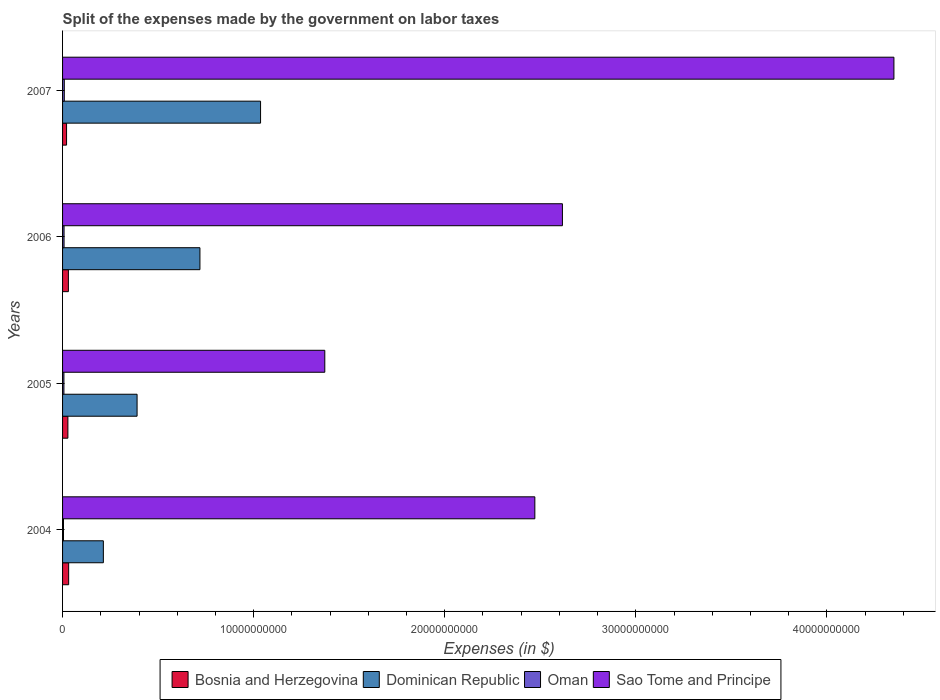How many groups of bars are there?
Ensure brevity in your answer.  4. How many bars are there on the 1st tick from the top?
Provide a short and direct response. 4. What is the label of the 4th group of bars from the top?
Make the answer very short. 2004. What is the expenses made by the government on labor taxes in Sao Tome and Principe in 2005?
Provide a short and direct response. 1.37e+1. Across all years, what is the maximum expenses made by the government on labor taxes in Dominican Republic?
Give a very brief answer. 1.04e+1. Across all years, what is the minimum expenses made by the government on labor taxes in Dominican Republic?
Offer a very short reply. 2.13e+09. In which year was the expenses made by the government on labor taxes in Dominican Republic minimum?
Provide a short and direct response. 2004. What is the total expenses made by the government on labor taxes in Dominican Republic in the graph?
Make the answer very short. 2.36e+1. What is the difference between the expenses made by the government on labor taxes in Sao Tome and Principe in 2004 and that in 2007?
Provide a short and direct response. -1.88e+1. What is the difference between the expenses made by the government on labor taxes in Sao Tome and Principe in 2004 and the expenses made by the government on labor taxes in Bosnia and Herzegovina in 2006?
Your response must be concise. 2.44e+1. What is the average expenses made by the government on labor taxes in Oman per year?
Your answer should be compact. 7.24e+07. In the year 2005, what is the difference between the expenses made by the government on labor taxes in Dominican Republic and expenses made by the government on labor taxes in Sao Tome and Principe?
Offer a very short reply. -9.82e+09. What is the ratio of the expenses made by the government on labor taxes in Bosnia and Herzegovina in 2004 to that in 2005?
Provide a short and direct response. 1.14. Is the expenses made by the government on labor taxes in Dominican Republic in 2005 less than that in 2006?
Your answer should be compact. Yes. Is the difference between the expenses made by the government on labor taxes in Dominican Republic in 2004 and 2007 greater than the difference between the expenses made by the government on labor taxes in Sao Tome and Principe in 2004 and 2007?
Your answer should be compact. Yes. What is the difference between the highest and the second highest expenses made by the government on labor taxes in Bosnia and Herzegovina?
Your answer should be compact. 1.43e+07. What is the difference between the highest and the lowest expenses made by the government on labor taxes in Oman?
Give a very brief answer. 4.18e+07. What does the 4th bar from the top in 2004 represents?
Provide a short and direct response. Bosnia and Herzegovina. What does the 1st bar from the bottom in 2006 represents?
Offer a very short reply. Bosnia and Herzegovina. Is it the case that in every year, the sum of the expenses made by the government on labor taxes in Bosnia and Herzegovina and expenses made by the government on labor taxes in Dominican Republic is greater than the expenses made by the government on labor taxes in Sao Tome and Principe?
Provide a succinct answer. No. How many bars are there?
Your answer should be very brief. 16. How many years are there in the graph?
Your answer should be compact. 4. Does the graph contain grids?
Give a very brief answer. No. Where does the legend appear in the graph?
Offer a very short reply. Bottom center. How are the legend labels stacked?
Your response must be concise. Horizontal. What is the title of the graph?
Your response must be concise. Split of the expenses made by the government on labor taxes. What is the label or title of the X-axis?
Ensure brevity in your answer.  Expenses (in $). What is the label or title of the Y-axis?
Make the answer very short. Years. What is the Expenses (in $) of Bosnia and Herzegovina in 2004?
Your answer should be very brief. 3.19e+08. What is the Expenses (in $) of Dominican Republic in 2004?
Give a very brief answer. 2.13e+09. What is the Expenses (in $) in Oman in 2004?
Your answer should be compact. 4.91e+07. What is the Expenses (in $) of Sao Tome and Principe in 2004?
Offer a very short reply. 2.47e+1. What is the Expenses (in $) in Bosnia and Herzegovina in 2005?
Make the answer very short. 2.79e+08. What is the Expenses (in $) in Dominican Republic in 2005?
Make the answer very short. 3.90e+09. What is the Expenses (in $) in Oman in 2005?
Make the answer very short. 7.12e+07. What is the Expenses (in $) in Sao Tome and Principe in 2005?
Make the answer very short. 1.37e+1. What is the Expenses (in $) in Bosnia and Herzegovina in 2006?
Ensure brevity in your answer.  3.04e+08. What is the Expenses (in $) in Dominican Republic in 2006?
Offer a terse response. 7.19e+09. What is the Expenses (in $) of Oman in 2006?
Offer a very short reply. 7.82e+07. What is the Expenses (in $) in Sao Tome and Principe in 2006?
Your response must be concise. 2.62e+1. What is the Expenses (in $) of Bosnia and Herzegovina in 2007?
Provide a succinct answer. 2.09e+08. What is the Expenses (in $) in Dominican Republic in 2007?
Your answer should be very brief. 1.04e+1. What is the Expenses (in $) in Oman in 2007?
Offer a very short reply. 9.09e+07. What is the Expenses (in $) in Sao Tome and Principe in 2007?
Provide a succinct answer. 4.35e+1. Across all years, what is the maximum Expenses (in $) in Bosnia and Herzegovina?
Provide a succinct answer. 3.19e+08. Across all years, what is the maximum Expenses (in $) of Dominican Republic?
Your answer should be very brief. 1.04e+1. Across all years, what is the maximum Expenses (in $) in Oman?
Provide a short and direct response. 9.09e+07. Across all years, what is the maximum Expenses (in $) in Sao Tome and Principe?
Provide a short and direct response. 4.35e+1. Across all years, what is the minimum Expenses (in $) in Bosnia and Herzegovina?
Make the answer very short. 2.09e+08. Across all years, what is the minimum Expenses (in $) of Dominican Republic?
Ensure brevity in your answer.  2.13e+09. Across all years, what is the minimum Expenses (in $) of Oman?
Offer a terse response. 4.91e+07. Across all years, what is the minimum Expenses (in $) of Sao Tome and Principe?
Ensure brevity in your answer.  1.37e+1. What is the total Expenses (in $) of Bosnia and Herzegovina in the graph?
Your answer should be compact. 1.11e+09. What is the total Expenses (in $) in Dominican Republic in the graph?
Provide a succinct answer. 2.36e+1. What is the total Expenses (in $) of Oman in the graph?
Your answer should be compact. 2.89e+08. What is the total Expenses (in $) of Sao Tome and Principe in the graph?
Offer a terse response. 1.08e+11. What is the difference between the Expenses (in $) of Bosnia and Herzegovina in 2004 and that in 2005?
Offer a very short reply. 3.98e+07. What is the difference between the Expenses (in $) of Dominican Republic in 2004 and that in 2005?
Offer a terse response. -1.76e+09. What is the difference between the Expenses (in $) of Oman in 2004 and that in 2005?
Ensure brevity in your answer.  -2.21e+07. What is the difference between the Expenses (in $) in Sao Tome and Principe in 2004 and that in 2005?
Your answer should be compact. 1.10e+1. What is the difference between the Expenses (in $) in Bosnia and Herzegovina in 2004 and that in 2006?
Your answer should be compact. 1.43e+07. What is the difference between the Expenses (in $) of Dominican Republic in 2004 and that in 2006?
Offer a very short reply. -5.05e+09. What is the difference between the Expenses (in $) of Oman in 2004 and that in 2006?
Make the answer very short. -2.91e+07. What is the difference between the Expenses (in $) in Sao Tome and Principe in 2004 and that in 2006?
Provide a succinct answer. -1.44e+09. What is the difference between the Expenses (in $) of Bosnia and Herzegovina in 2004 and that in 2007?
Offer a very short reply. 1.10e+08. What is the difference between the Expenses (in $) of Dominican Republic in 2004 and that in 2007?
Your response must be concise. -8.23e+09. What is the difference between the Expenses (in $) of Oman in 2004 and that in 2007?
Your response must be concise. -4.18e+07. What is the difference between the Expenses (in $) in Sao Tome and Principe in 2004 and that in 2007?
Provide a short and direct response. -1.88e+1. What is the difference between the Expenses (in $) of Bosnia and Herzegovina in 2005 and that in 2006?
Provide a succinct answer. -2.55e+07. What is the difference between the Expenses (in $) in Dominican Republic in 2005 and that in 2006?
Your response must be concise. -3.29e+09. What is the difference between the Expenses (in $) of Oman in 2005 and that in 2006?
Provide a short and direct response. -7.00e+06. What is the difference between the Expenses (in $) in Sao Tome and Principe in 2005 and that in 2006?
Your answer should be very brief. -1.24e+1. What is the difference between the Expenses (in $) in Bosnia and Herzegovina in 2005 and that in 2007?
Offer a terse response. 7.00e+07. What is the difference between the Expenses (in $) of Dominican Republic in 2005 and that in 2007?
Your response must be concise. -6.46e+09. What is the difference between the Expenses (in $) of Oman in 2005 and that in 2007?
Ensure brevity in your answer.  -1.97e+07. What is the difference between the Expenses (in $) in Sao Tome and Principe in 2005 and that in 2007?
Provide a succinct answer. -2.98e+1. What is the difference between the Expenses (in $) in Bosnia and Herzegovina in 2006 and that in 2007?
Your response must be concise. 9.55e+07. What is the difference between the Expenses (in $) in Dominican Republic in 2006 and that in 2007?
Provide a succinct answer. -3.17e+09. What is the difference between the Expenses (in $) in Oman in 2006 and that in 2007?
Provide a succinct answer. -1.27e+07. What is the difference between the Expenses (in $) in Sao Tome and Principe in 2006 and that in 2007?
Your response must be concise. -1.73e+1. What is the difference between the Expenses (in $) in Bosnia and Herzegovina in 2004 and the Expenses (in $) in Dominican Republic in 2005?
Your response must be concise. -3.58e+09. What is the difference between the Expenses (in $) of Bosnia and Herzegovina in 2004 and the Expenses (in $) of Oman in 2005?
Offer a very short reply. 2.48e+08. What is the difference between the Expenses (in $) in Bosnia and Herzegovina in 2004 and the Expenses (in $) in Sao Tome and Principe in 2005?
Give a very brief answer. -1.34e+1. What is the difference between the Expenses (in $) in Dominican Republic in 2004 and the Expenses (in $) in Oman in 2005?
Your answer should be compact. 2.06e+09. What is the difference between the Expenses (in $) of Dominican Republic in 2004 and the Expenses (in $) of Sao Tome and Principe in 2005?
Provide a short and direct response. -1.16e+1. What is the difference between the Expenses (in $) in Oman in 2004 and the Expenses (in $) in Sao Tome and Principe in 2005?
Provide a short and direct response. -1.37e+1. What is the difference between the Expenses (in $) in Bosnia and Herzegovina in 2004 and the Expenses (in $) in Dominican Republic in 2006?
Offer a terse response. -6.87e+09. What is the difference between the Expenses (in $) of Bosnia and Herzegovina in 2004 and the Expenses (in $) of Oman in 2006?
Provide a succinct answer. 2.41e+08. What is the difference between the Expenses (in $) of Bosnia and Herzegovina in 2004 and the Expenses (in $) of Sao Tome and Principe in 2006?
Your response must be concise. -2.58e+1. What is the difference between the Expenses (in $) of Dominican Republic in 2004 and the Expenses (in $) of Oman in 2006?
Your answer should be very brief. 2.06e+09. What is the difference between the Expenses (in $) of Dominican Republic in 2004 and the Expenses (in $) of Sao Tome and Principe in 2006?
Offer a terse response. -2.40e+1. What is the difference between the Expenses (in $) in Oman in 2004 and the Expenses (in $) in Sao Tome and Principe in 2006?
Your answer should be very brief. -2.61e+1. What is the difference between the Expenses (in $) of Bosnia and Herzegovina in 2004 and the Expenses (in $) of Dominican Republic in 2007?
Give a very brief answer. -1.00e+1. What is the difference between the Expenses (in $) in Bosnia and Herzegovina in 2004 and the Expenses (in $) in Oman in 2007?
Your response must be concise. 2.28e+08. What is the difference between the Expenses (in $) of Bosnia and Herzegovina in 2004 and the Expenses (in $) of Sao Tome and Principe in 2007?
Give a very brief answer. -4.32e+1. What is the difference between the Expenses (in $) of Dominican Republic in 2004 and the Expenses (in $) of Oman in 2007?
Provide a succinct answer. 2.04e+09. What is the difference between the Expenses (in $) of Dominican Republic in 2004 and the Expenses (in $) of Sao Tome and Principe in 2007?
Offer a terse response. -4.14e+1. What is the difference between the Expenses (in $) of Oman in 2004 and the Expenses (in $) of Sao Tome and Principe in 2007?
Offer a terse response. -4.35e+1. What is the difference between the Expenses (in $) in Bosnia and Herzegovina in 2005 and the Expenses (in $) in Dominican Republic in 2006?
Give a very brief answer. -6.91e+09. What is the difference between the Expenses (in $) of Bosnia and Herzegovina in 2005 and the Expenses (in $) of Oman in 2006?
Your answer should be very brief. 2.01e+08. What is the difference between the Expenses (in $) in Bosnia and Herzegovina in 2005 and the Expenses (in $) in Sao Tome and Principe in 2006?
Ensure brevity in your answer.  -2.59e+1. What is the difference between the Expenses (in $) of Dominican Republic in 2005 and the Expenses (in $) of Oman in 2006?
Provide a short and direct response. 3.82e+09. What is the difference between the Expenses (in $) of Dominican Republic in 2005 and the Expenses (in $) of Sao Tome and Principe in 2006?
Offer a terse response. -2.23e+1. What is the difference between the Expenses (in $) in Oman in 2005 and the Expenses (in $) in Sao Tome and Principe in 2006?
Give a very brief answer. -2.61e+1. What is the difference between the Expenses (in $) of Bosnia and Herzegovina in 2005 and the Expenses (in $) of Dominican Republic in 2007?
Offer a very short reply. -1.01e+1. What is the difference between the Expenses (in $) of Bosnia and Herzegovina in 2005 and the Expenses (in $) of Oman in 2007?
Your response must be concise. 1.88e+08. What is the difference between the Expenses (in $) in Bosnia and Herzegovina in 2005 and the Expenses (in $) in Sao Tome and Principe in 2007?
Ensure brevity in your answer.  -4.32e+1. What is the difference between the Expenses (in $) of Dominican Republic in 2005 and the Expenses (in $) of Oman in 2007?
Offer a very short reply. 3.81e+09. What is the difference between the Expenses (in $) in Dominican Republic in 2005 and the Expenses (in $) in Sao Tome and Principe in 2007?
Keep it short and to the point. -3.96e+1. What is the difference between the Expenses (in $) of Oman in 2005 and the Expenses (in $) of Sao Tome and Principe in 2007?
Give a very brief answer. -4.34e+1. What is the difference between the Expenses (in $) of Bosnia and Herzegovina in 2006 and the Expenses (in $) of Dominican Republic in 2007?
Provide a succinct answer. -1.01e+1. What is the difference between the Expenses (in $) in Bosnia and Herzegovina in 2006 and the Expenses (in $) in Oman in 2007?
Provide a short and direct response. 2.14e+08. What is the difference between the Expenses (in $) in Bosnia and Herzegovina in 2006 and the Expenses (in $) in Sao Tome and Principe in 2007?
Give a very brief answer. -4.32e+1. What is the difference between the Expenses (in $) in Dominican Republic in 2006 and the Expenses (in $) in Oman in 2007?
Provide a succinct answer. 7.10e+09. What is the difference between the Expenses (in $) of Dominican Republic in 2006 and the Expenses (in $) of Sao Tome and Principe in 2007?
Your answer should be very brief. -3.63e+1. What is the difference between the Expenses (in $) in Oman in 2006 and the Expenses (in $) in Sao Tome and Principe in 2007?
Keep it short and to the point. -4.34e+1. What is the average Expenses (in $) in Bosnia and Herzegovina per year?
Your answer should be very brief. 2.78e+08. What is the average Expenses (in $) in Dominican Republic per year?
Your response must be concise. 5.90e+09. What is the average Expenses (in $) in Oman per year?
Your answer should be very brief. 7.24e+07. What is the average Expenses (in $) of Sao Tome and Principe per year?
Keep it short and to the point. 2.70e+1. In the year 2004, what is the difference between the Expenses (in $) of Bosnia and Herzegovina and Expenses (in $) of Dominican Republic?
Keep it short and to the point. -1.82e+09. In the year 2004, what is the difference between the Expenses (in $) in Bosnia and Herzegovina and Expenses (in $) in Oman?
Your response must be concise. 2.70e+08. In the year 2004, what is the difference between the Expenses (in $) in Bosnia and Herzegovina and Expenses (in $) in Sao Tome and Principe?
Your response must be concise. -2.44e+1. In the year 2004, what is the difference between the Expenses (in $) in Dominican Republic and Expenses (in $) in Oman?
Offer a terse response. 2.09e+09. In the year 2004, what is the difference between the Expenses (in $) in Dominican Republic and Expenses (in $) in Sao Tome and Principe?
Your answer should be very brief. -2.26e+1. In the year 2004, what is the difference between the Expenses (in $) of Oman and Expenses (in $) of Sao Tome and Principe?
Keep it short and to the point. -2.47e+1. In the year 2005, what is the difference between the Expenses (in $) of Bosnia and Herzegovina and Expenses (in $) of Dominican Republic?
Your answer should be compact. -3.62e+09. In the year 2005, what is the difference between the Expenses (in $) in Bosnia and Herzegovina and Expenses (in $) in Oman?
Make the answer very short. 2.08e+08. In the year 2005, what is the difference between the Expenses (in $) in Bosnia and Herzegovina and Expenses (in $) in Sao Tome and Principe?
Keep it short and to the point. -1.34e+1. In the year 2005, what is the difference between the Expenses (in $) of Dominican Republic and Expenses (in $) of Oman?
Make the answer very short. 3.83e+09. In the year 2005, what is the difference between the Expenses (in $) of Dominican Republic and Expenses (in $) of Sao Tome and Principe?
Your response must be concise. -9.82e+09. In the year 2005, what is the difference between the Expenses (in $) in Oman and Expenses (in $) in Sao Tome and Principe?
Keep it short and to the point. -1.37e+1. In the year 2006, what is the difference between the Expenses (in $) in Bosnia and Herzegovina and Expenses (in $) in Dominican Republic?
Your answer should be very brief. -6.88e+09. In the year 2006, what is the difference between the Expenses (in $) in Bosnia and Herzegovina and Expenses (in $) in Oman?
Ensure brevity in your answer.  2.26e+08. In the year 2006, what is the difference between the Expenses (in $) in Bosnia and Herzegovina and Expenses (in $) in Sao Tome and Principe?
Ensure brevity in your answer.  -2.59e+1. In the year 2006, what is the difference between the Expenses (in $) of Dominican Republic and Expenses (in $) of Oman?
Your response must be concise. 7.11e+09. In the year 2006, what is the difference between the Expenses (in $) in Dominican Republic and Expenses (in $) in Sao Tome and Principe?
Provide a short and direct response. -1.90e+1. In the year 2006, what is the difference between the Expenses (in $) in Oman and Expenses (in $) in Sao Tome and Principe?
Your response must be concise. -2.61e+1. In the year 2007, what is the difference between the Expenses (in $) in Bosnia and Herzegovina and Expenses (in $) in Dominican Republic?
Offer a terse response. -1.02e+1. In the year 2007, what is the difference between the Expenses (in $) in Bosnia and Herzegovina and Expenses (in $) in Oman?
Give a very brief answer. 1.18e+08. In the year 2007, what is the difference between the Expenses (in $) in Bosnia and Herzegovina and Expenses (in $) in Sao Tome and Principe?
Offer a very short reply. -4.33e+1. In the year 2007, what is the difference between the Expenses (in $) of Dominican Republic and Expenses (in $) of Oman?
Offer a very short reply. 1.03e+1. In the year 2007, what is the difference between the Expenses (in $) in Dominican Republic and Expenses (in $) in Sao Tome and Principe?
Provide a succinct answer. -3.31e+1. In the year 2007, what is the difference between the Expenses (in $) in Oman and Expenses (in $) in Sao Tome and Principe?
Make the answer very short. -4.34e+1. What is the ratio of the Expenses (in $) in Bosnia and Herzegovina in 2004 to that in 2005?
Provide a short and direct response. 1.14. What is the ratio of the Expenses (in $) in Dominican Republic in 2004 to that in 2005?
Make the answer very short. 0.55. What is the ratio of the Expenses (in $) in Oman in 2004 to that in 2005?
Provide a succinct answer. 0.69. What is the ratio of the Expenses (in $) of Sao Tome and Principe in 2004 to that in 2005?
Your answer should be very brief. 1.8. What is the ratio of the Expenses (in $) of Bosnia and Herzegovina in 2004 to that in 2006?
Provide a succinct answer. 1.05. What is the ratio of the Expenses (in $) of Dominican Republic in 2004 to that in 2006?
Offer a very short reply. 0.3. What is the ratio of the Expenses (in $) in Oman in 2004 to that in 2006?
Your answer should be compact. 0.63. What is the ratio of the Expenses (in $) in Sao Tome and Principe in 2004 to that in 2006?
Your response must be concise. 0.94. What is the ratio of the Expenses (in $) in Bosnia and Herzegovina in 2004 to that in 2007?
Provide a short and direct response. 1.53. What is the ratio of the Expenses (in $) in Dominican Republic in 2004 to that in 2007?
Your response must be concise. 0.21. What is the ratio of the Expenses (in $) of Oman in 2004 to that in 2007?
Provide a succinct answer. 0.54. What is the ratio of the Expenses (in $) in Sao Tome and Principe in 2004 to that in 2007?
Your answer should be very brief. 0.57. What is the ratio of the Expenses (in $) in Bosnia and Herzegovina in 2005 to that in 2006?
Provide a succinct answer. 0.92. What is the ratio of the Expenses (in $) of Dominican Republic in 2005 to that in 2006?
Offer a very short reply. 0.54. What is the ratio of the Expenses (in $) in Oman in 2005 to that in 2006?
Make the answer very short. 0.91. What is the ratio of the Expenses (in $) of Sao Tome and Principe in 2005 to that in 2006?
Provide a short and direct response. 0.52. What is the ratio of the Expenses (in $) of Bosnia and Herzegovina in 2005 to that in 2007?
Keep it short and to the point. 1.34. What is the ratio of the Expenses (in $) in Dominican Republic in 2005 to that in 2007?
Provide a succinct answer. 0.38. What is the ratio of the Expenses (in $) of Oman in 2005 to that in 2007?
Your answer should be compact. 0.78. What is the ratio of the Expenses (in $) in Sao Tome and Principe in 2005 to that in 2007?
Your answer should be very brief. 0.32. What is the ratio of the Expenses (in $) in Bosnia and Herzegovina in 2006 to that in 2007?
Ensure brevity in your answer.  1.46. What is the ratio of the Expenses (in $) of Dominican Republic in 2006 to that in 2007?
Your answer should be compact. 0.69. What is the ratio of the Expenses (in $) in Oman in 2006 to that in 2007?
Make the answer very short. 0.86. What is the ratio of the Expenses (in $) in Sao Tome and Principe in 2006 to that in 2007?
Your answer should be very brief. 0.6. What is the difference between the highest and the second highest Expenses (in $) of Bosnia and Herzegovina?
Your response must be concise. 1.43e+07. What is the difference between the highest and the second highest Expenses (in $) of Dominican Republic?
Offer a terse response. 3.17e+09. What is the difference between the highest and the second highest Expenses (in $) in Oman?
Offer a very short reply. 1.27e+07. What is the difference between the highest and the second highest Expenses (in $) of Sao Tome and Principe?
Offer a very short reply. 1.73e+1. What is the difference between the highest and the lowest Expenses (in $) of Bosnia and Herzegovina?
Make the answer very short. 1.10e+08. What is the difference between the highest and the lowest Expenses (in $) in Dominican Republic?
Give a very brief answer. 8.23e+09. What is the difference between the highest and the lowest Expenses (in $) in Oman?
Make the answer very short. 4.18e+07. What is the difference between the highest and the lowest Expenses (in $) in Sao Tome and Principe?
Offer a very short reply. 2.98e+1. 